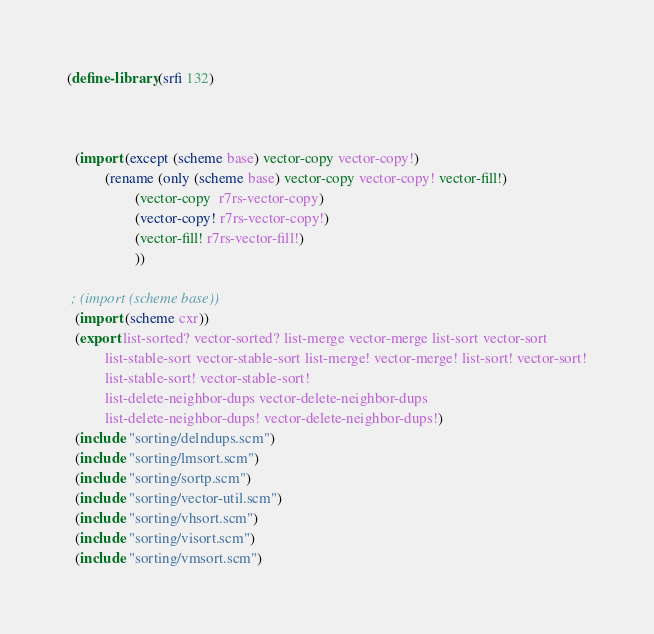<code> <loc_0><loc_0><loc_500><loc_500><_Scheme_>(define-library (srfi 132)



  (import (except (scheme base) vector-copy vector-copy!)
          (rename (only (scheme base) vector-copy vector-copy! vector-fill!)
                  (vector-copy  r7rs-vector-copy)
                  (vector-copy! r7rs-vector-copy!)
                  (vector-fill! r7rs-vector-fill!)
                  ))

 ; (import (scheme base))
  (import (scheme cxr))
  (export list-sorted? vector-sorted? list-merge vector-merge list-sort vector-sort
          list-stable-sort vector-stable-sort list-merge! vector-merge! list-sort! vector-sort!
          list-stable-sort! vector-stable-sort!
          list-delete-neighbor-dups vector-delete-neighbor-dups
          list-delete-neighbor-dups! vector-delete-neighbor-dups!)
  (include "sorting/delndups.scm")
  (include "sorting/lmsort.scm")
  (include "sorting/sortp.scm")
  (include "sorting/vector-util.scm")
  (include "sorting/vhsort.scm")
  (include "sorting/visort.scm")
  (include "sorting/vmsort.scm")</code> 